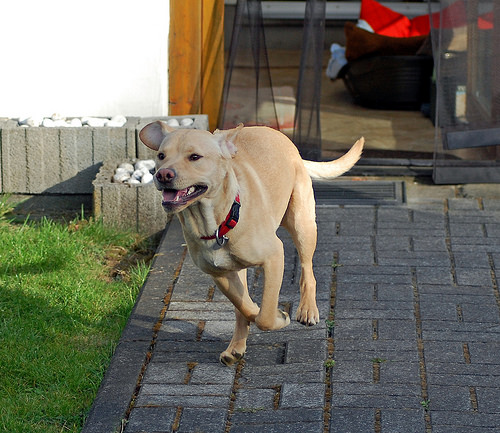<image>
Is there a dog on the floor? Yes. Looking at the image, I can see the dog is positioned on top of the floor, with the floor providing support. Is there a dog to the right of the block? Yes. From this viewpoint, the dog is positioned to the right side relative to the block. 